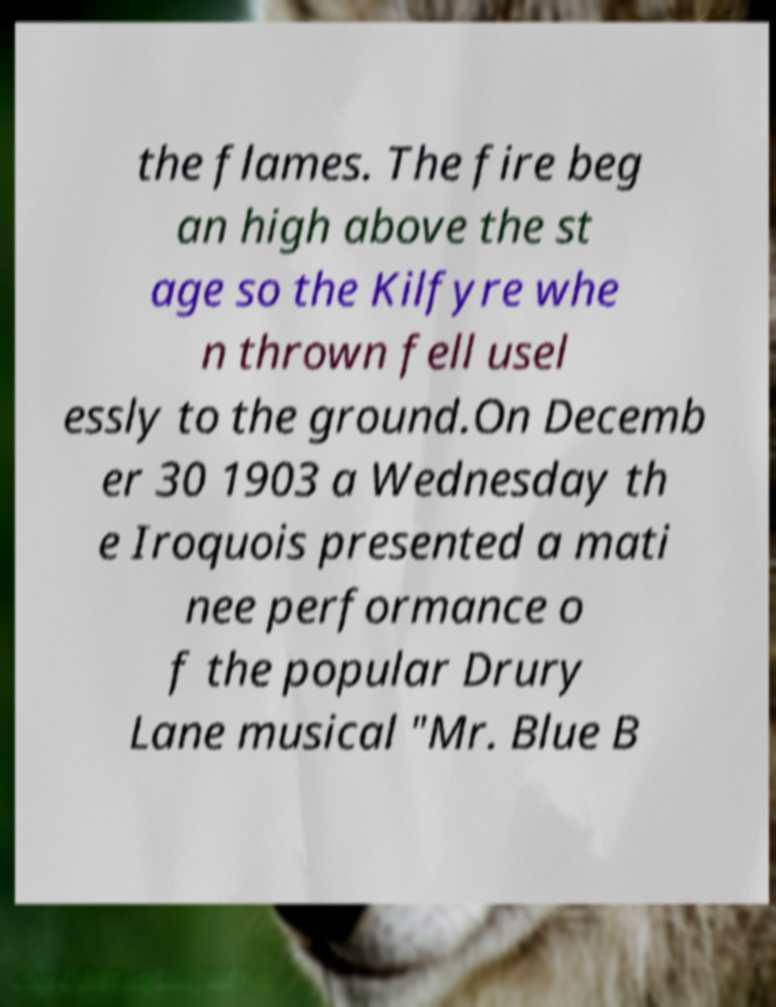Please identify and transcribe the text found in this image. the flames. The fire beg an high above the st age so the Kilfyre whe n thrown fell usel essly to the ground.On Decemb er 30 1903 a Wednesday th e Iroquois presented a mati nee performance o f the popular Drury Lane musical "Mr. Blue B 